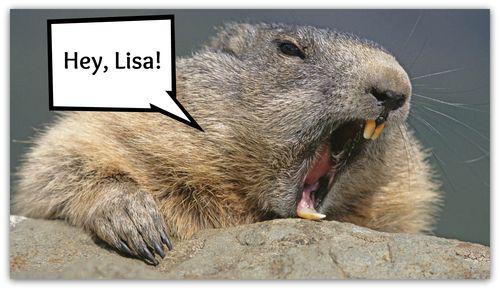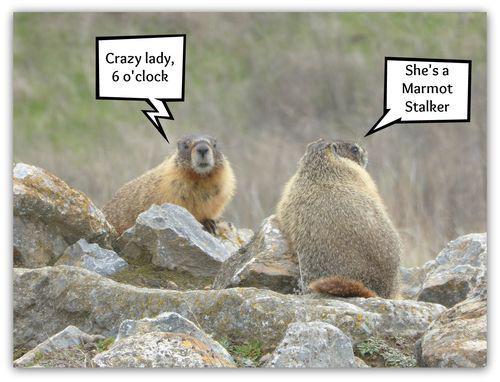The first image is the image on the left, the second image is the image on the right. Evaluate the accuracy of this statement regarding the images: "the creature in the left image has its mouth wide open". Is it true? Answer yes or no. Yes. The first image is the image on the left, the second image is the image on the right. Given the left and right images, does the statement "There are green fields in both of them." hold true? Answer yes or no. No. 